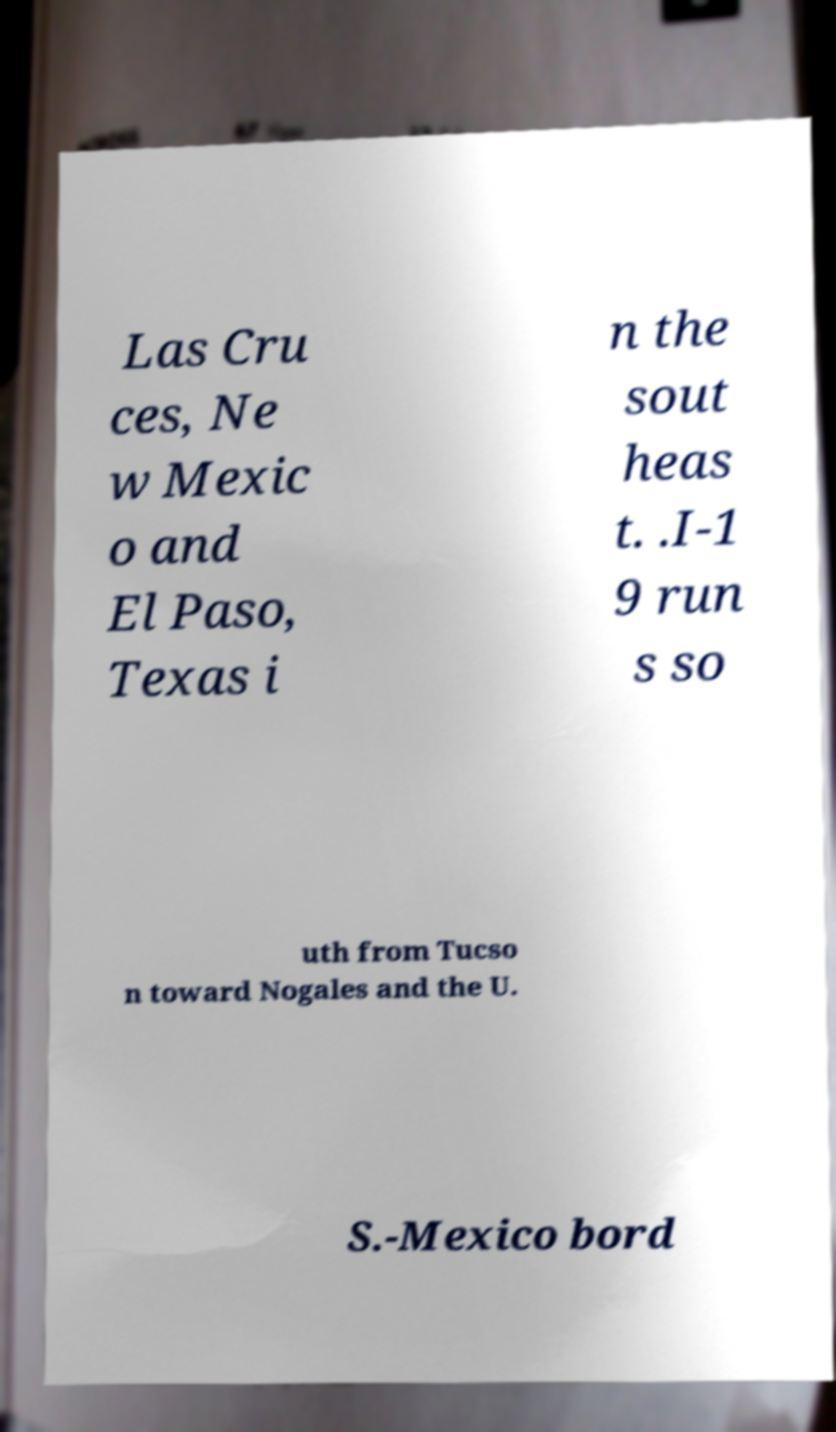Please identify and transcribe the text found in this image. Las Cru ces, Ne w Mexic o and El Paso, Texas i n the sout heas t. .I-1 9 run s so uth from Tucso n toward Nogales and the U. S.-Mexico bord 